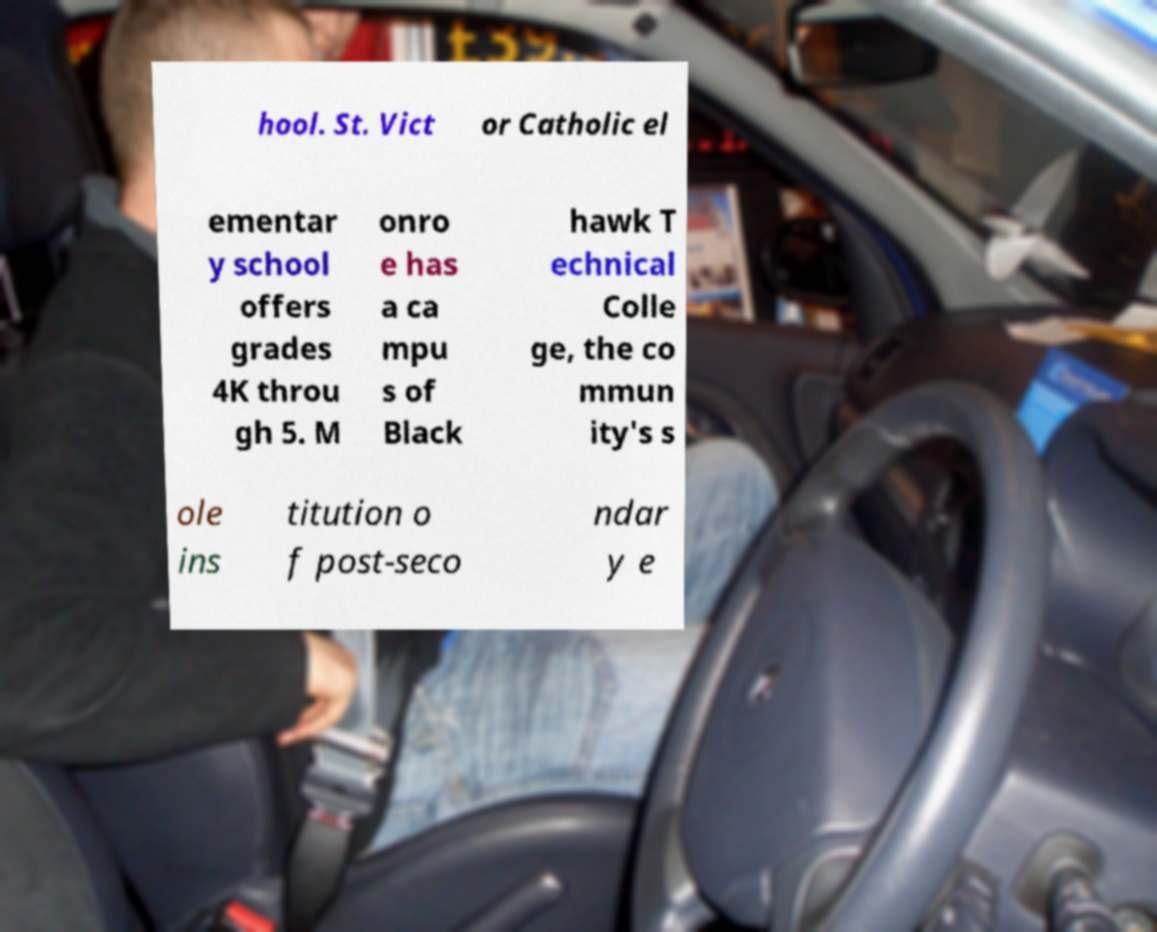I need the written content from this picture converted into text. Can you do that? hool. St. Vict or Catholic el ementar y school offers grades 4K throu gh 5. M onro e has a ca mpu s of Black hawk T echnical Colle ge, the co mmun ity's s ole ins titution o f post-seco ndar y e 